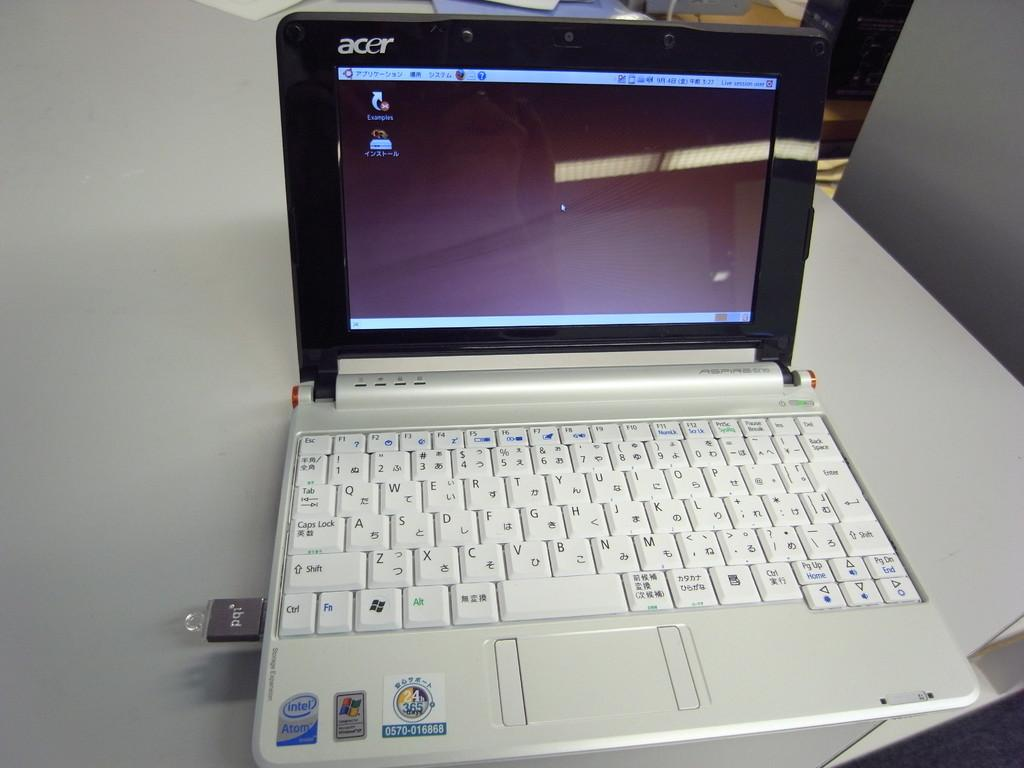What electronic device is on the table in the image? There is a laptop on the table in the image. What is connected to the laptop? A: A pen drive is plugged into the laptop. Can you describe any objects or features visible in the background of the image? Unfortunately, the provided facts do not give any specific details about the background of the image. How many cars are parked in the background of the image? There are no cars visible in the background of the image. What type of cracker is being used as a bookmark in the image? There is no cracker present in the image. 